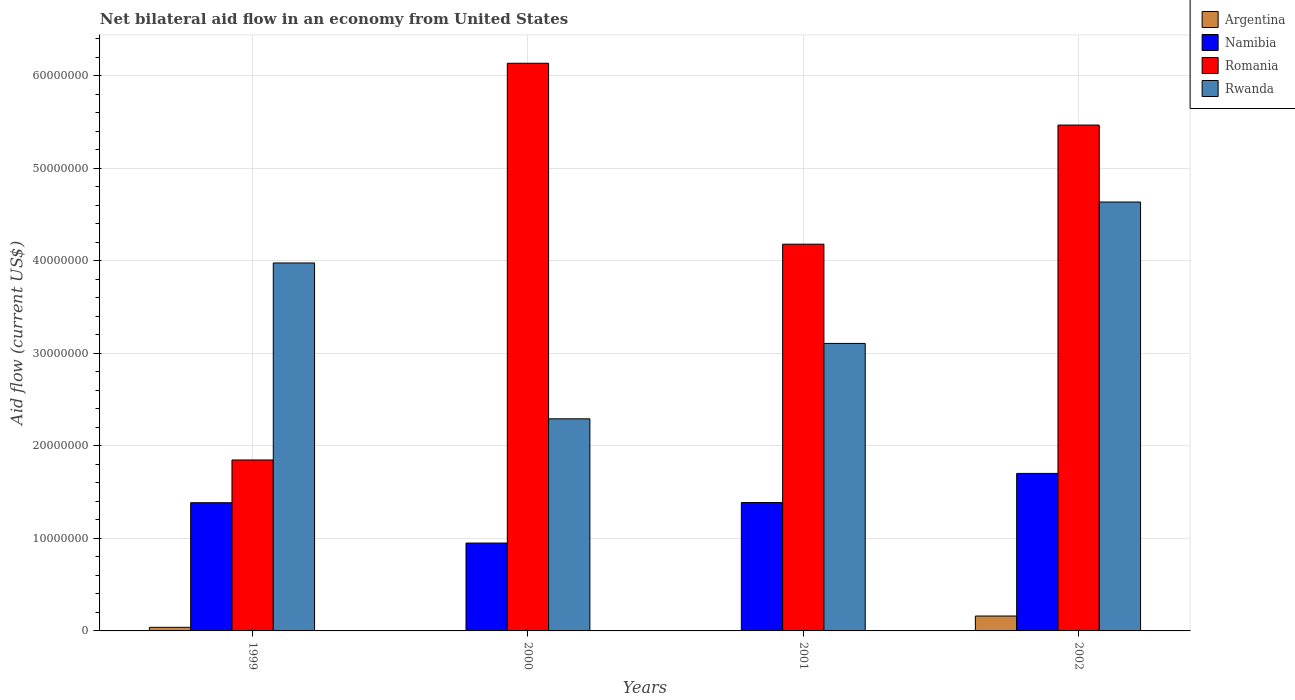How many different coloured bars are there?
Provide a succinct answer. 4. Are the number of bars on each tick of the X-axis equal?
Provide a short and direct response. No. How many bars are there on the 1st tick from the right?
Provide a succinct answer. 4. In how many cases, is the number of bars for a given year not equal to the number of legend labels?
Make the answer very short. 2. What is the net bilateral aid flow in Argentina in 1999?
Offer a very short reply. 3.90e+05. Across all years, what is the maximum net bilateral aid flow in Namibia?
Provide a short and direct response. 1.70e+07. Across all years, what is the minimum net bilateral aid flow in Romania?
Your response must be concise. 1.85e+07. What is the total net bilateral aid flow in Argentina in the graph?
Offer a terse response. 2.00e+06. What is the difference between the net bilateral aid flow in Argentina in 1999 and that in 2002?
Keep it short and to the point. -1.22e+06. What is the difference between the net bilateral aid flow in Namibia in 2001 and the net bilateral aid flow in Argentina in 1999?
Ensure brevity in your answer.  1.35e+07. What is the average net bilateral aid flow in Argentina per year?
Your answer should be compact. 5.00e+05. In the year 1999, what is the difference between the net bilateral aid flow in Romania and net bilateral aid flow in Namibia?
Your response must be concise. 4.62e+06. In how many years, is the net bilateral aid flow in Rwanda greater than 60000000 US$?
Ensure brevity in your answer.  0. What is the ratio of the net bilateral aid flow in Romania in 1999 to that in 2001?
Your answer should be compact. 0.44. Is the net bilateral aid flow in Romania in 2001 less than that in 2002?
Keep it short and to the point. Yes. Is the difference between the net bilateral aid flow in Romania in 2000 and 2002 greater than the difference between the net bilateral aid flow in Namibia in 2000 and 2002?
Offer a terse response. Yes. What is the difference between the highest and the second highest net bilateral aid flow in Namibia?
Your answer should be very brief. 3.15e+06. What is the difference between the highest and the lowest net bilateral aid flow in Argentina?
Give a very brief answer. 1.61e+06. Is it the case that in every year, the sum of the net bilateral aid flow in Argentina and net bilateral aid flow in Rwanda is greater than the sum of net bilateral aid flow in Romania and net bilateral aid flow in Namibia?
Offer a very short reply. No. Are all the bars in the graph horizontal?
Provide a short and direct response. No. How many years are there in the graph?
Provide a succinct answer. 4. What is the difference between two consecutive major ticks on the Y-axis?
Provide a short and direct response. 1.00e+07. Are the values on the major ticks of Y-axis written in scientific E-notation?
Provide a short and direct response. No. Does the graph contain any zero values?
Your answer should be very brief. Yes. Where does the legend appear in the graph?
Provide a short and direct response. Top right. How are the legend labels stacked?
Your answer should be very brief. Vertical. What is the title of the graph?
Offer a very short reply. Net bilateral aid flow in an economy from United States. Does "Macedonia" appear as one of the legend labels in the graph?
Provide a short and direct response. No. What is the label or title of the X-axis?
Keep it short and to the point. Years. What is the label or title of the Y-axis?
Keep it short and to the point. Aid flow (current US$). What is the Aid flow (current US$) of Namibia in 1999?
Your answer should be compact. 1.39e+07. What is the Aid flow (current US$) of Romania in 1999?
Your answer should be compact. 1.85e+07. What is the Aid flow (current US$) of Rwanda in 1999?
Give a very brief answer. 3.98e+07. What is the Aid flow (current US$) of Namibia in 2000?
Your answer should be very brief. 9.50e+06. What is the Aid flow (current US$) in Romania in 2000?
Ensure brevity in your answer.  6.14e+07. What is the Aid flow (current US$) in Rwanda in 2000?
Your response must be concise. 2.29e+07. What is the Aid flow (current US$) in Argentina in 2001?
Your response must be concise. 0. What is the Aid flow (current US$) of Namibia in 2001?
Keep it short and to the point. 1.39e+07. What is the Aid flow (current US$) in Romania in 2001?
Make the answer very short. 4.18e+07. What is the Aid flow (current US$) in Rwanda in 2001?
Your response must be concise. 3.11e+07. What is the Aid flow (current US$) of Argentina in 2002?
Ensure brevity in your answer.  1.61e+06. What is the Aid flow (current US$) in Namibia in 2002?
Provide a succinct answer. 1.70e+07. What is the Aid flow (current US$) of Romania in 2002?
Ensure brevity in your answer.  5.47e+07. What is the Aid flow (current US$) of Rwanda in 2002?
Your answer should be very brief. 4.64e+07. Across all years, what is the maximum Aid flow (current US$) in Argentina?
Make the answer very short. 1.61e+06. Across all years, what is the maximum Aid flow (current US$) of Namibia?
Ensure brevity in your answer.  1.70e+07. Across all years, what is the maximum Aid flow (current US$) of Romania?
Your response must be concise. 6.14e+07. Across all years, what is the maximum Aid flow (current US$) of Rwanda?
Offer a terse response. 4.64e+07. Across all years, what is the minimum Aid flow (current US$) of Argentina?
Give a very brief answer. 0. Across all years, what is the minimum Aid flow (current US$) in Namibia?
Your answer should be compact. 9.50e+06. Across all years, what is the minimum Aid flow (current US$) in Romania?
Provide a succinct answer. 1.85e+07. Across all years, what is the minimum Aid flow (current US$) in Rwanda?
Your answer should be compact. 2.29e+07. What is the total Aid flow (current US$) in Argentina in the graph?
Your answer should be compact. 2.00e+06. What is the total Aid flow (current US$) in Namibia in the graph?
Provide a succinct answer. 5.43e+07. What is the total Aid flow (current US$) of Romania in the graph?
Provide a short and direct response. 1.76e+08. What is the total Aid flow (current US$) in Rwanda in the graph?
Offer a very short reply. 1.40e+08. What is the difference between the Aid flow (current US$) of Namibia in 1999 and that in 2000?
Ensure brevity in your answer.  4.36e+06. What is the difference between the Aid flow (current US$) in Romania in 1999 and that in 2000?
Keep it short and to the point. -4.29e+07. What is the difference between the Aid flow (current US$) of Rwanda in 1999 and that in 2000?
Provide a succinct answer. 1.68e+07. What is the difference between the Aid flow (current US$) of Romania in 1999 and that in 2001?
Give a very brief answer. -2.33e+07. What is the difference between the Aid flow (current US$) in Rwanda in 1999 and that in 2001?
Your response must be concise. 8.70e+06. What is the difference between the Aid flow (current US$) of Argentina in 1999 and that in 2002?
Offer a very short reply. -1.22e+06. What is the difference between the Aid flow (current US$) in Namibia in 1999 and that in 2002?
Keep it short and to the point. -3.17e+06. What is the difference between the Aid flow (current US$) in Romania in 1999 and that in 2002?
Give a very brief answer. -3.62e+07. What is the difference between the Aid flow (current US$) of Rwanda in 1999 and that in 2002?
Your answer should be compact. -6.59e+06. What is the difference between the Aid flow (current US$) of Namibia in 2000 and that in 2001?
Provide a succinct answer. -4.38e+06. What is the difference between the Aid flow (current US$) in Romania in 2000 and that in 2001?
Your answer should be compact. 1.96e+07. What is the difference between the Aid flow (current US$) of Rwanda in 2000 and that in 2001?
Give a very brief answer. -8.15e+06. What is the difference between the Aid flow (current US$) of Namibia in 2000 and that in 2002?
Provide a succinct answer. -7.53e+06. What is the difference between the Aid flow (current US$) in Romania in 2000 and that in 2002?
Offer a terse response. 6.68e+06. What is the difference between the Aid flow (current US$) in Rwanda in 2000 and that in 2002?
Give a very brief answer. -2.34e+07. What is the difference between the Aid flow (current US$) of Namibia in 2001 and that in 2002?
Ensure brevity in your answer.  -3.15e+06. What is the difference between the Aid flow (current US$) of Romania in 2001 and that in 2002?
Offer a very short reply. -1.29e+07. What is the difference between the Aid flow (current US$) in Rwanda in 2001 and that in 2002?
Your answer should be very brief. -1.53e+07. What is the difference between the Aid flow (current US$) of Argentina in 1999 and the Aid flow (current US$) of Namibia in 2000?
Offer a very short reply. -9.11e+06. What is the difference between the Aid flow (current US$) of Argentina in 1999 and the Aid flow (current US$) of Romania in 2000?
Keep it short and to the point. -6.10e+07. What is the difference between the Aid flow (current US$) of Argentina in 1999 and the Aid flow (current US$) of Rwanda in 2000?
Provide a short and direct response. -2.25e+07. What is the difference between the Aid flow (current US$) of Namibia in 1999 and the Aid flow (current US$) of Romania in 2000?
Give a very brief answer. -4.75e+07. What is the difference between the Aid flow (current US$) of Namibia in 1999 and the Aid flow (current US$) of Rwanda in 2000?
Give a very brief answer. -9.07e+06. What is the difference between the Aid flow (current US$) in Romania in 1999 and the Aid flow (current US$) in Rwanda in 2000?
Give a very brief answer. -4.45e+06. What is the difference between the Aid flow (current US$) in Argentina in 1999 and the Aid flow (current US$) in Namibia in 2001?
Keep it short and to the point. -1.35e+07. What is the difference between the Aid flow (current US$) of Argentina in 1999 and the Aid flow (current US$) of Romania in 2001?
Give a very brief answer. -4.14e+07. What is the difference between the Aid flow (current US$) of Argentina in 1999 and the Aid flow (current US$) of Rwanda in 2001?
Offer a terse response. -3.07e+07. What is the difference between the Aid flow (current US$) of Namibia in 1999 and the Aid flow (current US$) of Romania in 2001?
Your response must be concise. -2.80e+07. What is the difference between the Aid flow (current US$) in Namibia in 1999 and the Aid flow (current US$) in Rwanda in 2001?
Give a very brief answer. -1.72e+07. What is the difference between the Aid flow (current US$) of Romania in 1999 and the Aid flow (current US$) of Rwanda in 2001?
Your response must be concise. -1.26e+07. What is the difference between the Aid flow (current US$) in Argentina in 1999 and the Aid flow (current US$) in Namibia in 2002?
Provide a succinct answer. -1.66e+07. What is the difference between the Aid flow (current US$) of Argentina in 1999 and the Aid flow (current US$) of Romania in 2002?
Ensure brevity in your answer.  -5.43e+07. What is the difference between the Aid flow (current US$) of Argentina in 1999 and the Aid flow (current US$) of Rwanda in 2002?
Your response must be concise. -4.60e+07. What is the difference between the Aid flow (current US$) in Namibia in 1999 and the Aid flow (current US$) in Romania in 2002?
Make the answer very short. -4.08e+07. What is the difference between the Aid flow (current US$) in Namibia in 1999 and the Aid flow (current US$) in Rwanda in 2002?
Keep it short and to the point. -3.25e+07. What is the difference between the Aid flow (current US$) of Romania in 1999 and the Aid flow (current US$) of Rwanda in 2002?
Provide a succinct answer. -2.79e+07. What is the difference between the Aid flow (current US$) of Namibia in 2000 and the Aid flow (current US$) of Romania in 2001?
Make the answer very short. -3.23e+07. What is the difference between the Aid flow (current US$) of Namibia in 2000 and the Aid flow (current US$) of Rwanda in 2001?
Provide a short and direct response. -2.16e+07. What is the difference between the Aid flow (current US$) of Romania in 2000 and the Aid flow (current US$) of Rwanda in 2001?
Give a very brief answer. 3.03e+07. What is the difference between the Aid flow (current US$) in Namibia in 2000 and the Aid flow (current US$) in Romania in 2002?
Give a very brief answer. -4.52e+07. What is the difference between the Aid flow (current US$) of Namibia in 2000 and the Aid flow (current US$) of Rwanda in 2002?
Provide a succinct answer. -3.69e+07. What is the difference between the Aid flow (current US$) in Romania in 2000 and the Aid flow (current US$) in Rwanda in 2002?
Ensure brevity in your answer.  1.50e+07. What is the difference between the Aid flow (current US$) in Namibia in 2001 and the Aid flow (current US$) in Romania in 2002?
Provide a succinct answer. -4.08e+07. What is the difference between the Aid flow (current US$) in Namibia in 2001 and the Aid flow (current US$) in Rwanda in 2002?
Provide a succinct answer. -3.25e+07. What is the difference between the Aid flow (current US$) of Romania in 2001 and the Aid flow (current US$) of Rwanda in 2002?
Make the answer very short. -4.56e+06. What is the average Aid flow (current US$) of Namibia per year?
Ensure brevity in your answer.  1.36e+07. What is the average Aid flow (current US$) of Romania per year?
Make the answer very short. 4.41e+07. What is the average Aid flow (current US$) in Rwanda per year?
Ensure brevity in your answer.  3.50e+07. In the year 1999, what is the difference between the Aid flow (current US$) of Argentina and Aid flow (current US$) of Namibia?
Provide a succinct answer. -1.35e+07. In the year 1999, what is the difference between the Aid flow (current US$) of Argentina and Aid flow (current US$) of Romania?
Give a very brief answer. -1.81e+07. In the year 1999, what is the difference between the Aid flow (current US$) in Argentina and Aid flow (current US$) in Rwanda?
Your response must be concise. -3.94e+07. In the year 1999, what is the difference between the Aid flow (current US$) of Namibia and Aid flow (current US$) of Romania?
Keep it short and to the point. -4.62e+06. In the year 1999, what is the difference between the Aid flow (current US$) of Namibia and Aid flow (current US$) of Rwanda?
Make the answer very short. -2.59e+07. In the year 1999, what is the difference between the Aid flow (current US$) of Romania and Aid flow (current US$) of Rwanda?
Give a very brief answer. -2.13e+07. In the year 2000, what is the difference between the Aid flow (current US$) of Namibia and Aid flow (current US$) of Romania?
Make the answer very short. -5.19e+07. In the year 2000, what is the difference between the Aid flow (current US$) in Namibia and Aid flow (current US$) in Rwanda?
Provide a succinct answer. -1.34e+07. In the year 2000, what is the difference between the Aid flow (current US$) in Romania and Aid flow (current US$) in Rwanda?
Provide a succinct answer. 3.84e+07. In the year 2001, what is the difference between the Aid flow (current US$) in Namibia and Aid flow (current US$) in Romania?
Your response must be concise. -2.79e+07. In the year 2001, what is the difference between the Aid flow (current US$) in Namibia and Aid flow (current US$) in Rwanda?
Provide a succinct answer. -1.72e+07. In the year 2001, what is the difference between the Aid flow (current US$) in Romania and Aid flow (current US$) in Rwanda?
Your response must be concise. 1.07e+07. In the year 2002, what is the difference between the Aid flow (current US$) in Argentina and Aid flow (current US$) in Namibia?
Provide a succinct answer. -1.54e+07. In the year 2002, what is the difference between the Aid flow (current US$) in Argentina and Aid flow (current US$) in Romania?
Your response must be concise. -5.31e+07. In the year 2002, what is the difference between the Aid flow (current US$) in Argentina and Aid flow (current US$) in Rwanda?
Offer a terse response. -4.48e+07. In the year 2002, what is the difference between the Aid flow (current US$) of Namibia and Aid flow (current US$) of Romania?
Give a very brief answer. -3.77e+07. In the year 2002, what is the difference between the Aid flow (current US$) of Namibia and Aid flow (current US$) of Rwanda?
Ensure brevity in your answer.  -2.93e+07. In the year 2002, what is the difference between the Aid flow (current US$) in Romania and Aid flow (current US$) in Rwanda?
Your response must be concise. 8.32e+06. What is the ratio of the Aid flow (current US$) in Namibia in 1999 to that in 2000?
Ensure brevity in your answer.  1.46. What is the ratio of the Aid flow (current US$) in Romania in 1999 to that in 2000?
Ensure brevity in your answer.  0.3. What is the ratio of the Aid flow (current US$) of Rwanda in 1999 to that in 2000?
Offer a terse response. 1.73. What is the ratio of the Aid flow (current US$) of Namibia in 1999 to that in 2001?
Your answer should be compact. 1. What is the ratio of the Aid flow (current US$) of Romania in 1999 to that in 2001?
Give a very brief answer. 0.44. What is the ratio of the Aid flow (current US$) in Rwanda in 1999 to that in 2001?
Provide a succinct answer. 1.28. What is the ratio of the Aid flow (current US$) of Argentina in 1999 to that in 2002?
Your response must be concise. 0.24. What is the ratio of the Aid flow (current US$) in Namibia in 1999 to that in 2002?
Offer a very short reply. 0.81. What is the ratio of the Aid flow (current US$) in Romania in 1999 to that in 2002?
Your answer should be very brief. 0.34. What is the ratio of the Aid flow (current US$) of Rwanda in 1999 to that in 2002?
Keep it short and to the point. 0.86. What is the ratio of the Aid flow (current US$) of Namibia in 2000 to that in 2001?
Keep it short and to the point. 0.68. What is the ratio of the Aid flow (current US$) of Romania in 2000 to that in 2001?
Your answer should be very brief. 1.47. What is the ratio of the Aid flow (current US$) in Rwanda in 2000 to that in 2001?
Offer a terse response. 0.74. What is the ratio of the Aid flow (current US$) of Namibia in 2000 to that in 2002?
Provide a short and direct response. 0.56. What is the ratio of the Aid flow (current US$) of Romania in 2000 to that in 2002?
Offer a very short reply. 1.12. What is the ratio of the Aid flow (current US$) in Rwanda in 2000 to that in 2002?
Give a very brief answer. 0.49. What is the ratio of the Aid flow (current US$) of Namibia in 2001 to that in 2002?
Offer a terse response. 0.81. What is the ratio of the Aid flow (current US$) in Romania in 2001 to that in 2002?
Provide a short and direct response. 0.76. What is the ratio of the Aid flow (current US$) of Rwanda in 2001 to that in 2002?
Give a very brief answer. 0.67. What is the difference between the highest and the second highest Aid flow (current US$) of Namibia?
Ensure brevity in your answer.  3.15e+06. What is the difference between the highest and the second highest Aid flow (current US$) in Romania?
Offer a terse response. 6.68e+06. What is the difference between the highest and the second highest Aid flow (current US$) in Rwanda?
Provide a short and direct response. 6.59e+06. What is the difference between the highest and the lowest Aid flow (current US$) in Argentina?
Ensure brevity in your answer.  1.61e+06. What is the difference between the highest and the lowest Aid flow (current US$) in Namibia?
Your answer should be very brief. 7.53e+06. What is the difference between the highest and the lowest Aid flow (current US$) of Romania?
Keep it short and to the point. 4.29e+07. What is the difference between the highest and the lowest Aid flow (current US$) of Rwanda?
Offer a very short reply. 2.34e+07. 